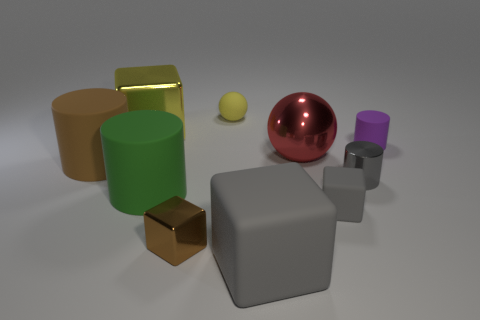Subtract all yellow cylinders. Subtract all cyan balls. How many cylinders are left? 4 Subtract all cylinders. How many objects are left? 6 Add 8 large brown cylinders. How many large brown cylinders are left? 9 Add 7 big rubber balls. How many big rubber balls exist? 7 Subtract 0 brown balls. How many objects are left? 10 Subtract all tiny gray shiny balls. Subtract all red objects. How many objects are left? 9 